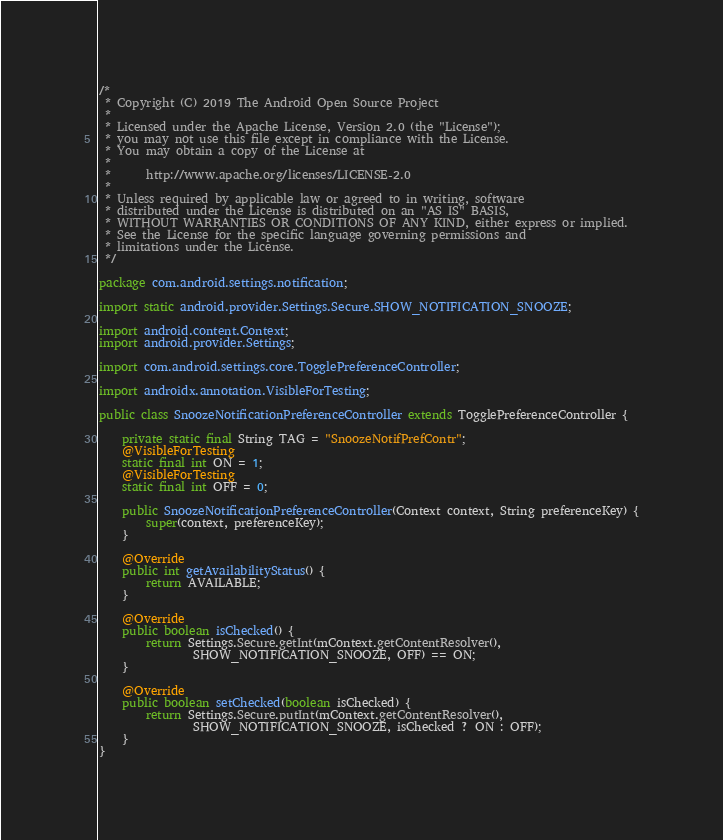<code> <loc_0><loc_0><loc_500><loc_500><_Java_>/*
 * Copyright (C) 2019 The Android Open Source Project
 *
 * Licensed under the Apache License, Version 2.0 (the "License");
 * you may not use this file except in compliance with the License.
 * You may obtain a copy of the License at
 *
 *      http://www.apache.org/licenses/LICENSE-2.0
 *
 * Unless required by applicable law or agreed to in writing, software
 * distributed under the License is distributed on an "AS IS" BASIS,
 * WITHOUT WARRANTIES OR CONDITIONS OF ANY KIND, either express or implied.
 * See the License for the specific language governing permissions and
 * limitations under the License.
 */

package com.android.settings.notification;

import static android.provider.Settings.Secure.SHOW_NOTIFICATION_SNOOZE;

import android.content.Context;
import android.provider.Settings;

import com.android.settings.core.TogglePreferenceController;

import androidx.annotation.VisibleForTesting;

public class SnoozeNotificationPreferenceController extends TogglePreferenceController {

    private static final String TAG = "SnoozeNotifPrefContr";
    @VisibleForTesting
    static final int ON = 1;
    @VisibleForTesting
    static final int OFF = 0;

    public SnoozeNotificationPreferenceController(Context context, String preferenceKey) {
        super(context, preferenceKey);
    }

    @Override
    public int getAvailabilityStatus() {
        return AVAILABLE;
    }

    @Override
    public boolean isChecked() {
        return Settings.Secure.getInt(mContext.getContentResolver(),
                SHOW_NOTIFICATION_SNOOZE, OFF) == ON;
    }

    @Override
    public boolean setChecked(boolean isChecked) {
        return Settings.Secure.putInt(mContext.getContentResolver(),
                SHOW_NOTIFICATION_SNOOZE, isChecked ? ON : OFF);
    }
}
</code> 